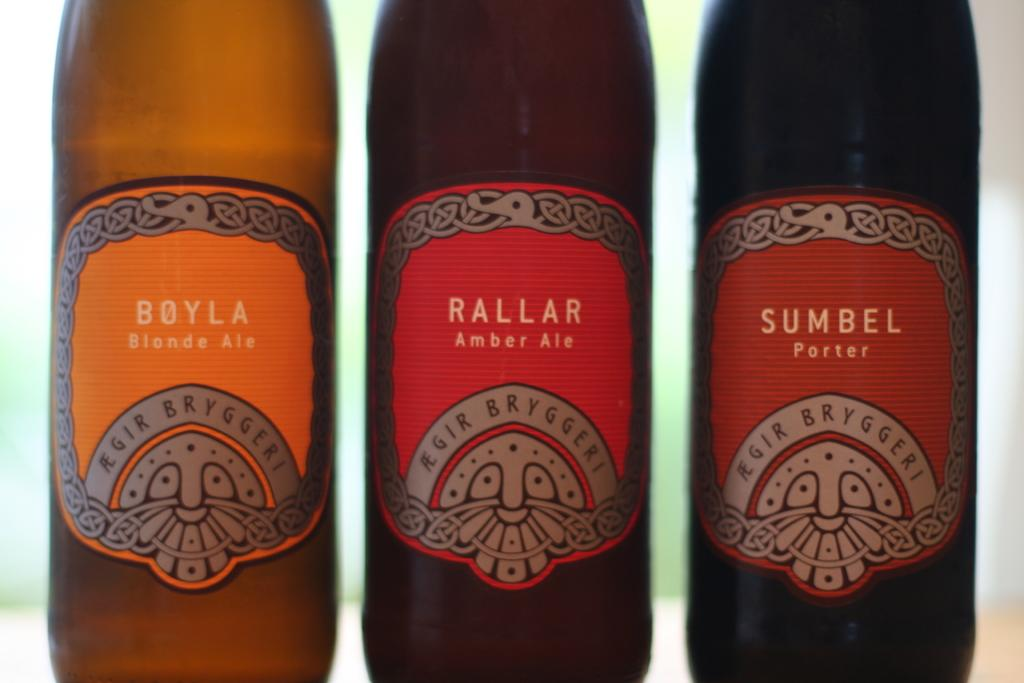<image>
Describe the image concisely. the name Rallar that are on bottles with each other 